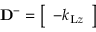<formula> <loc_0><loc_0><loc_500><loc_500>D ^ { - } = \left [ \begin{array} { l } { - k _ { L z } } \end{array} \right ]</formula> 